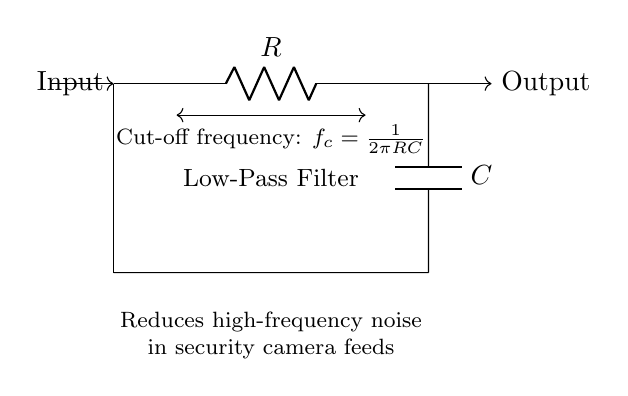What components are in the circuit? The circuit comprises a resistor and a capacitor, which are fundamental components of the low-pass filter. The resistor (R) is connected in series with the capacitor (C), which is connected to the ground.
Answer: Resistor, capacitor What is the purpose of this low-pass filter? The low-pass filter is designed to reduce high-frequency noise in security camera feeds, allowing lower frequency signals to pass while attenuating higher frequencies.
Answer: Noise reduction What do the arrows indicate in the circuit? The arrows indicate the direction of the input and output signals. The input signal enters the circuit on the left and the output signal leaves the circuit on the right.
Answer: Signal direction What is the cut-off frequency formula? The cut-off frequency formula for this circuit is given as f_c equals one divided by two pi multiplied by R and C. This formula helps to determine the frequency at which the output starts to decrease in amplitude.
Answer: f_c = 1/(2πRC) How does the resistor affect the circuit's operation? The resistor affects the circuit’s operation by determining the time constant when paired with the capacitor, which influences the cut-off frequency of the filter. A higher resistance increases the cut-off frequency, reducing high-frequency signals more effectively.
Answer: Determines time constant What happens to high-frequency signals in this circuit? High-frequency signals are attenuated as they pass through the low-pass filter, meaning their amplitude is reduced significantly while lower frequency signals are allowed to pass through with minimal attenuation.
Answer: Attenuated What is the impact of increasing the capacitor's value? Increasing the capacitor's value lowers the cut-off frequency, causing the filter to allow even fewer high-frequency signals to pass, hence more effective noise reduction.
Answer: Lowers cut-off frequency 